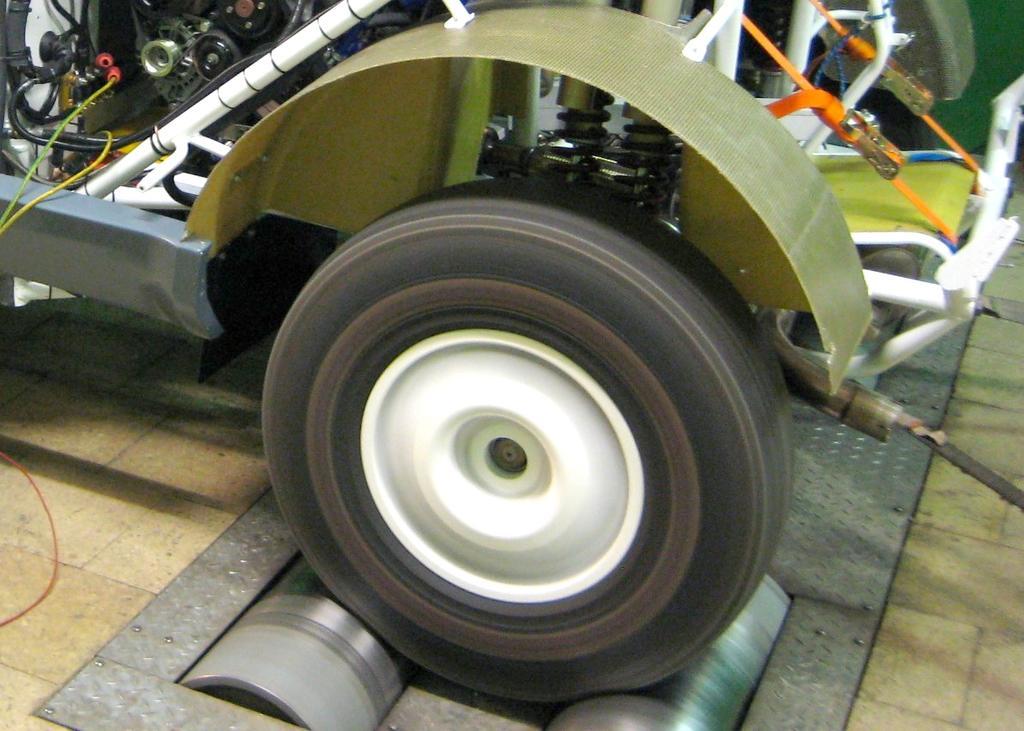Could you give a brief overview of what you see in this image? As we can see in the image there is a vehicle. 